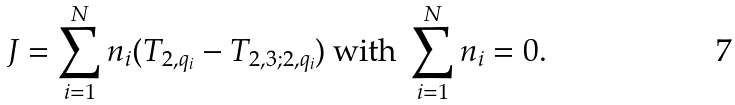<formula> <loc_0><loc_0><loc_500><loc_500>J = \sum _ { i = 1 } ^ { N } n _ { i } ( T _ { 2 , q _ { i } } - T _ { 2 , 3 ; 2 , q _ { i } } ) \text { with } \sum _ { i = 1 } ^ { N } n _ { i } = 0 .</formula> 